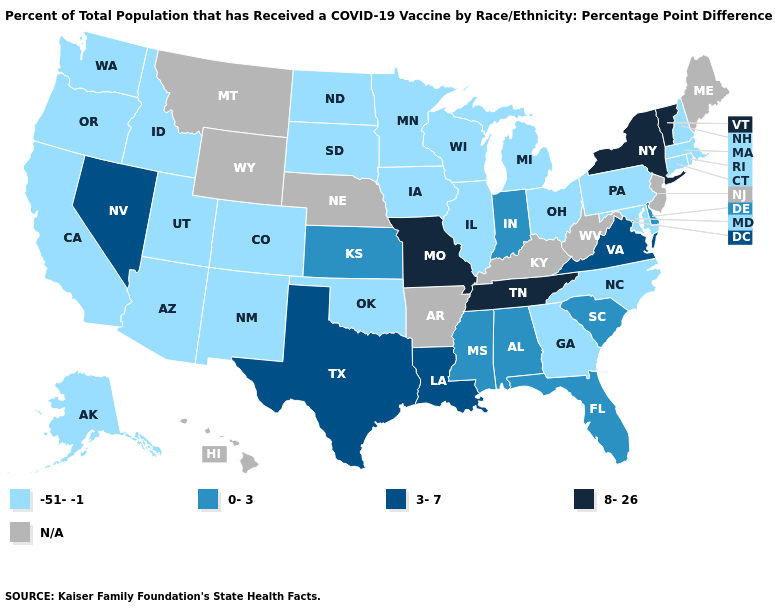Name the states that have a value in the range -51--1?
Quick response, please. Alaska, Arizona, California, Colorado, Connecticut, Georgia, Idaho, Illinois, Iowa, Maryland, Massachusetts, Michigan, Minnesota, New Hampshire, New Mexico, North Carolina, North Dakota, Ohio, Oklahoma, Oregon, Pennsylvania, Rhode Island, South Dakota, Utah, Washington, Wisconsin. What is the lowest value in states that border Missouri?
Give a very brief answer. -51--1. Which states have the lowest value in the USA?
Be succinct. Alaska, Arizona, California, Colorado, Connecticut, Georgia, Idaho, Illinois, Iowa, Maryland, Massachusetts, Michigan, Minnesota, New Hampshire, New Mexico, North Carolina, North Dakota, Ohio, Oklahoma, Oregon, Pennsylvania, Rhode Island, South Dakota, Utah, Washington, Wisconsin. What is the value of South Dakota?
Quick response, please. -51--1. Does the map have missing data?
Be succinct. Yes. What is the value of North Carolina?
Write a very short answer. -51--1. Which states have the lowest value in the MidWest?
Concise answer only. Illinois, Iowa, Michigan, Minnesota, North Dakota, Ohio, South Dakota, Wisconsin. What is the lowest value in the MidWest?
Write a very short answer. -51--1. Among the states that border Kansas , does Missouri have the highest value?
Give a very brief answer. Yes. What is the value of Louisiana?
Quick response, please. 3-7. What is the value of Maryland?
Write a very short answer. -51--1. Does the first symbol in the legend represent the smallest category?
Write a very short answer. Yes. Which states have the lowest value in the South?
Be succinct. Georgia, Maryland, North Carolina, Oklahoma. How many symbols are there in the legend?
Be succinct. 5. 